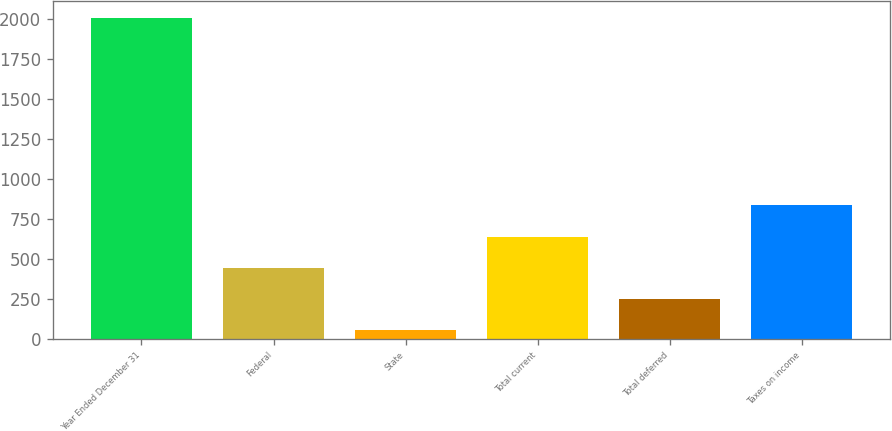<chart> <loc_0><loc_0><loc_500><loc_500><bar_chart><fcel>Year Ended December 31<fcel>Federal<fcel>State<fcel>Total current<fcel>Total deferred<fcel>Taxes on income<nl><fcel>2011<fcel>443.8<fcel>52<fcel>639.7<fcel>247.9<fcel>835.6<nl></chart> 